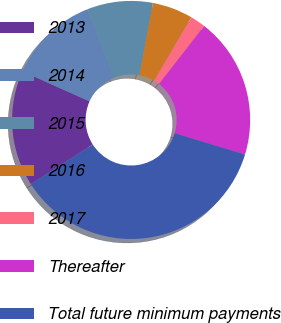<chart> <loc_0><loc_0><loc_500><loc_500><pie_chart><fcel>2013<fcel>2014<fcel>2015<fcel>2016<fcel>2017<fcel>Thereafter<fcel>Total future minimum payments<nl><fcel>15.75%<fcel>12.33%<fcel>8.91%<fcel>5.5%<fcel>2.08%<fcel>19.17%<fcel>36.26%<nl></chart> 